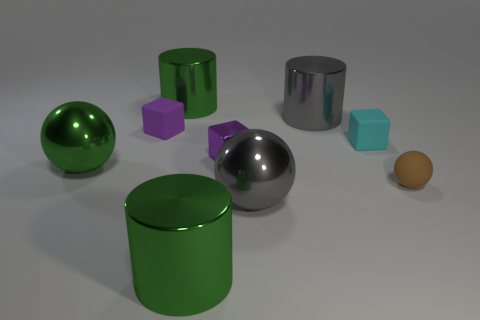Can you tell me the different colors of objects present in the image? Certainly! The objects display a variety of colors: there is a green sphere, two green cylinders—one appearing a shade lighter than the other—, a silver sphere and cylinder, a small purple cube, a small teal cube, and a small orange sphere. 